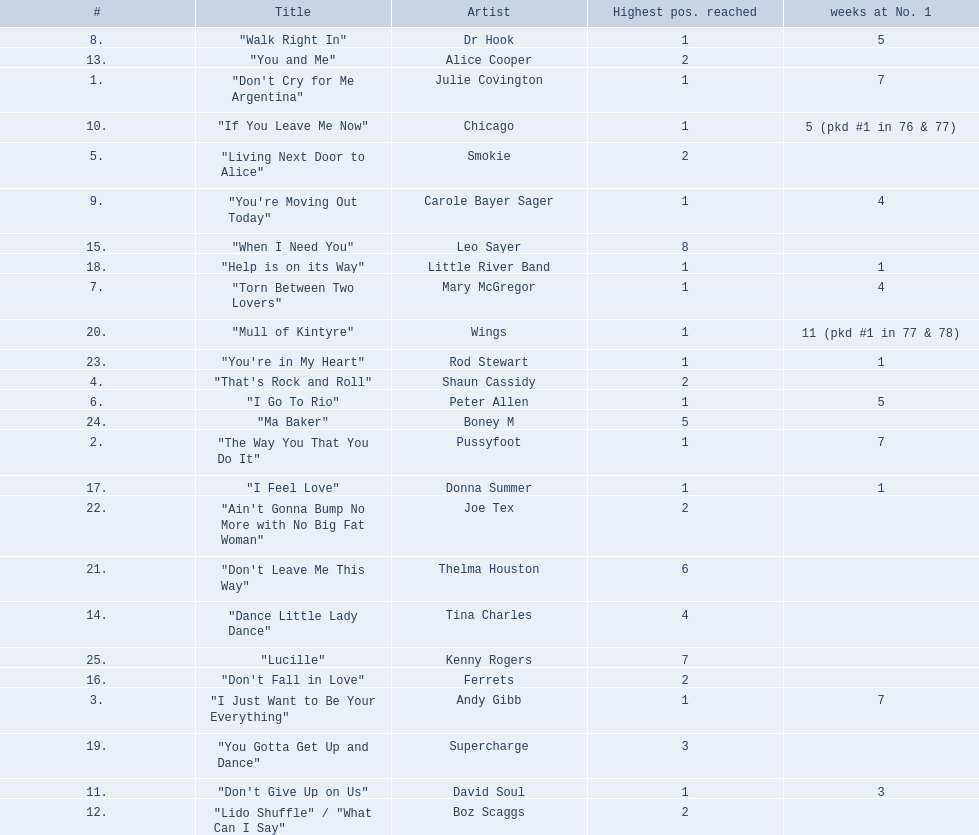How long is the longest amount of time spent at number 1? 11 (pkd #1 in 77 & 78). What song spent 11 weeks at number 1? "Mull of Kintyre". What band had a number 1 hit with this song? Wings. 